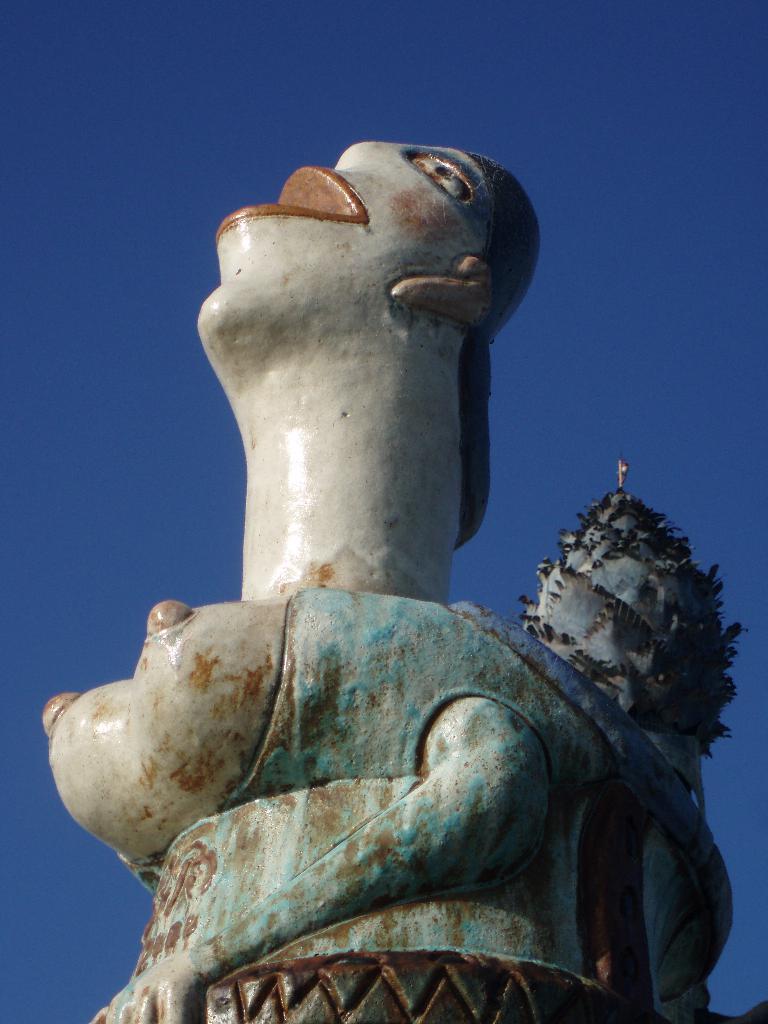Could you give a brief overview of what you see in this image? In this image we can see a sculpture and in the background, we can see the sky. 